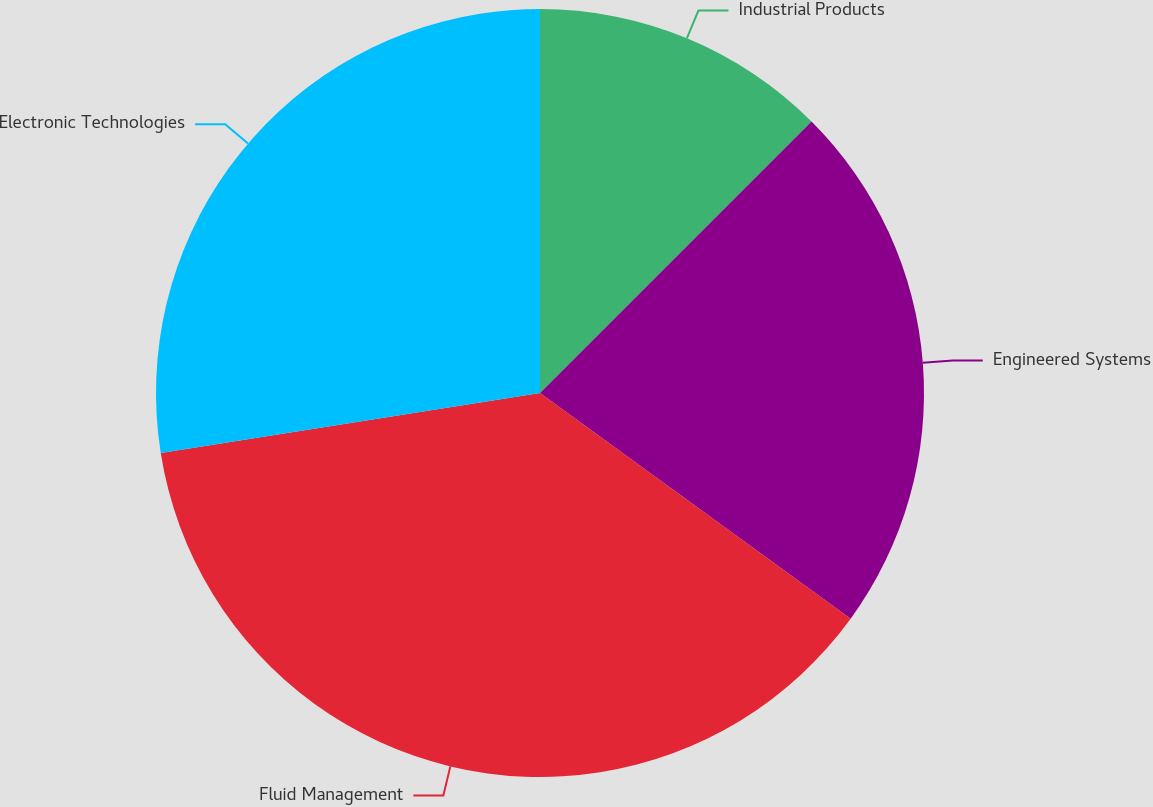Convert chart to OTSL. <chart><loc_0><loc_0><loc_500><loc_500><pie_chart><fcel>Industrial Products<fcel>Engineered Systems<fcel>Fluid Management<fcel>Electronic Technologies<nl><fcel>12.5%<fcel>22.5%<fcel>37.5%<fcel>27.5%<nl></chart> 